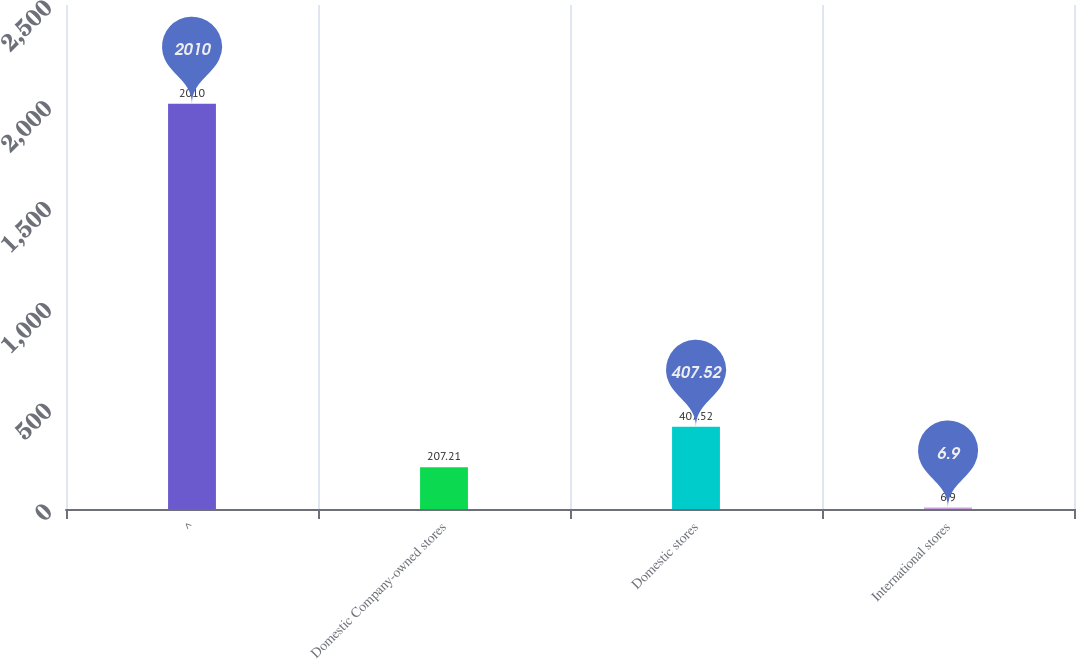Convert chart to OTSL. <chart><loc_0><loc_0><loc_500><loc_500><bar_chart><fcel>^<fcel>Domestic Company-owned stores<fcel>Domestic stores<fcel>International stores<nl><fcel>2010<fcel>207.21<fcel>407.52<fcel>6.9<nl></chart> 